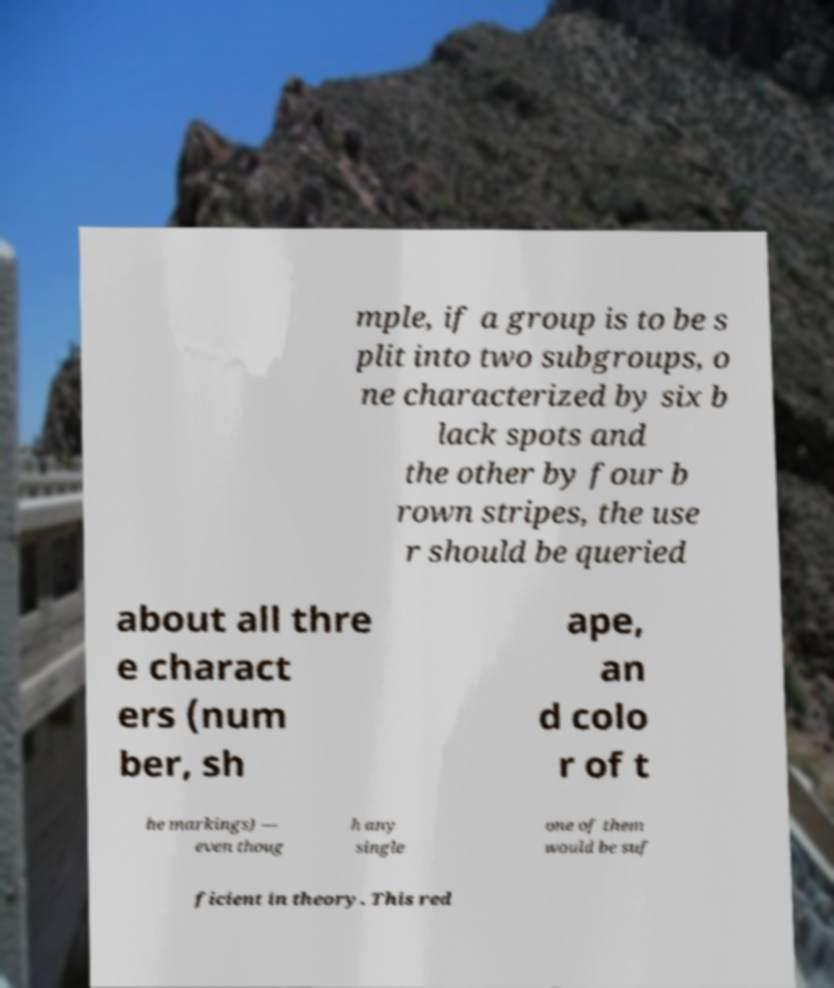There's text embedded in this image that I need extracted. Can you transcribe it verbatim? mple, if a group is to be s plit into two subgroups, o ne characterized by six b lack spots and the other by four b rown stripes, the use r should be queried about all thre e charact ers (num ber, sh ape, an d colo r of t he markings) — even thoug h any single one of them would be suf ficient in theory. This red 